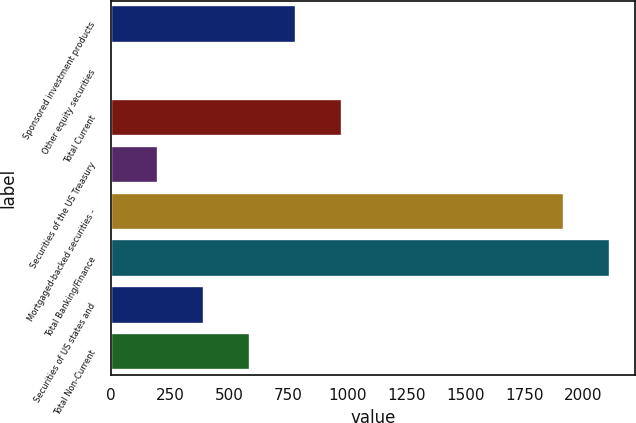<chart> <loc_0><loc_0><loc_500><loc_500><bar_chart><fcel>Sponsored investment products<fcel>Other equity securities<fcel>Total Current<fcel>Securities of the US Treasury<fcel>Mortgaged-backed securities -<fcel>Total Banking/Finance<fcel>Securities of US states and<fcel>Total Non-Current<nl><fcel>782.2<fcel>5<fcel>976.5<fcel>199.3<fcel>1918<fcel>2112.3<fcel>393.6<fcel>587.9<nl></chart> 